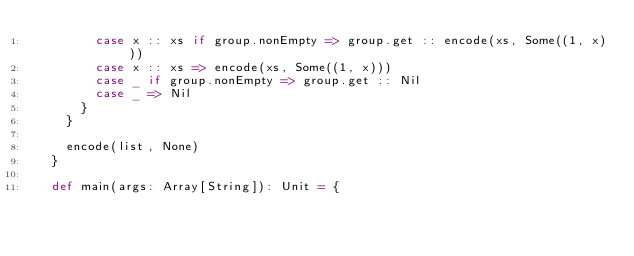Convert code to text. <code><loc_0><loc_0><loc_500><loc_500><_Scala_>        case x :: xs if group.nonEmpty => group.get :: encode(xs, Some((1, x)))
        case x :: xs => encode(xs, Some((1, x)))
        case _ if group.nonEmpty => group.get :: Nil
        case _ => Nil
      }
    }

    encode(list, None)
  }

  def main(args: Array[String]): Unit = {</code> 